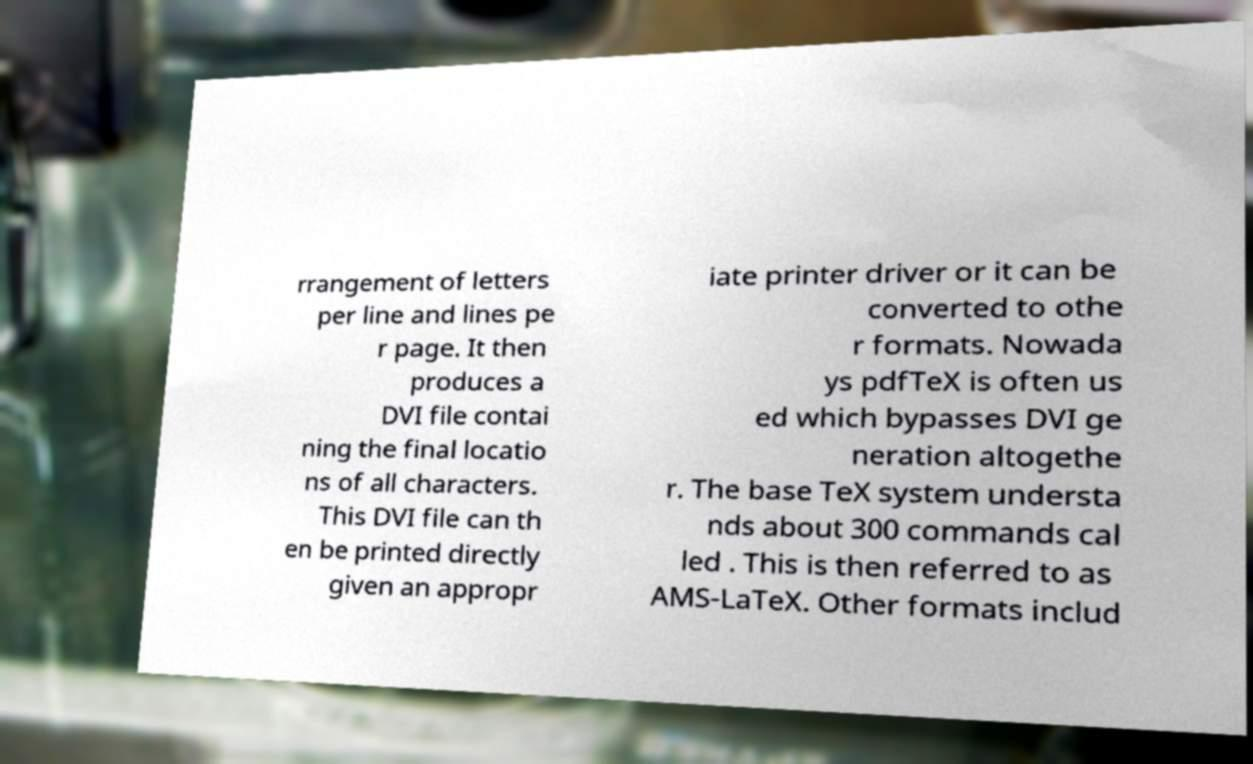What messages or text are displayed in this image? I need them in a readable, typed format. rrangement of letters per line and lines pe r page. It then produces a DVI file contai ning the final locatio ns of all characters. This DVI file can th en be printed directly given an appropr iate printer driver or it can be converted to othe r formats. Nowada ys pdfTeX is often us ed which bypasses DVI ge neration altogethe r. The base TeX system understa nds about 300 commands cal led . This is then referred to as AMS-LaTeX. Other formats includ 